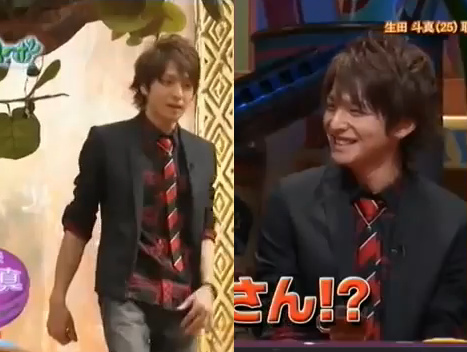Can you describe the attire of the man on the right? The man on the right is dressed in a black jacket over a red and black striped tie and a dark shirt. His hairstyle appears to be well-kept and he is smiling, suggesting he might be enjoying the conversation or event. 